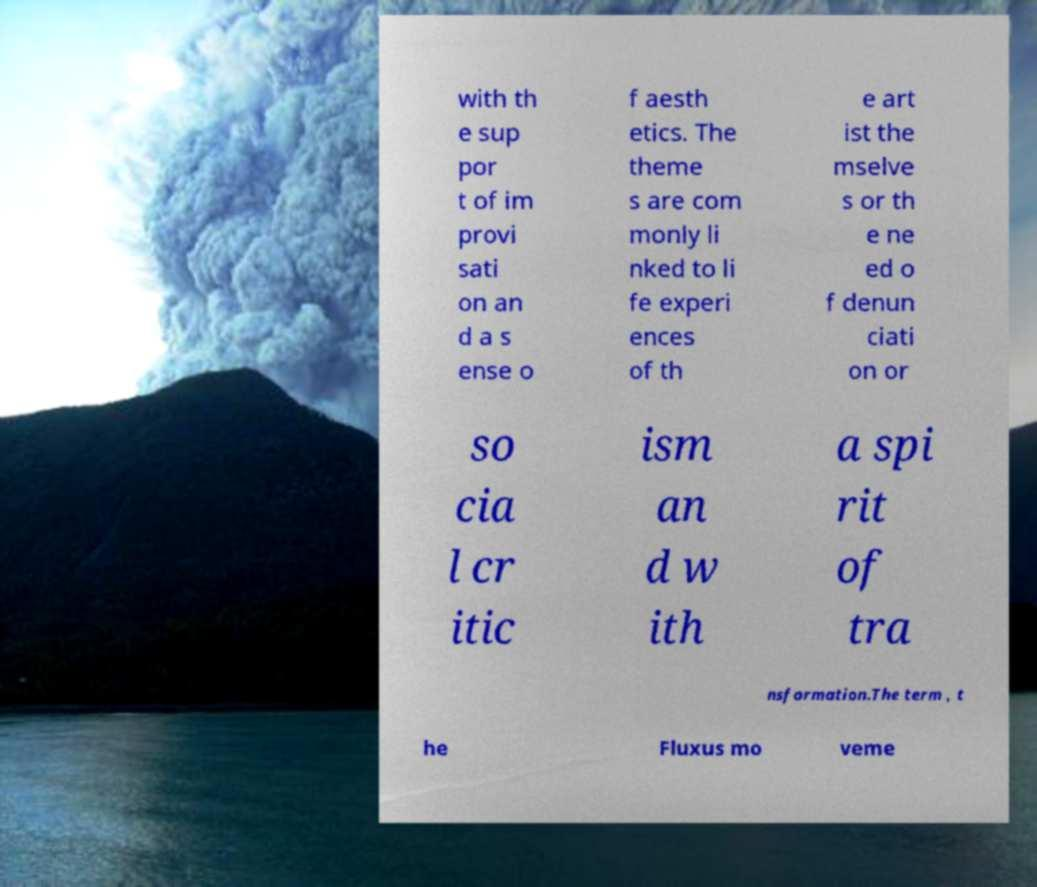For documentation purposes, I need the text within this image transcribed. Could you provide that? with th e sup por t of im provi sati on an d a s ense o f aesth etics. The theme s are com monly li nked to li fe experi ences of th e art ist the mselve s or th e ne ed o f denun ciati on or so cia l cr itic ism an d w ith a spi rit of tra nsformation.The term , t he Fluxus mo veme 